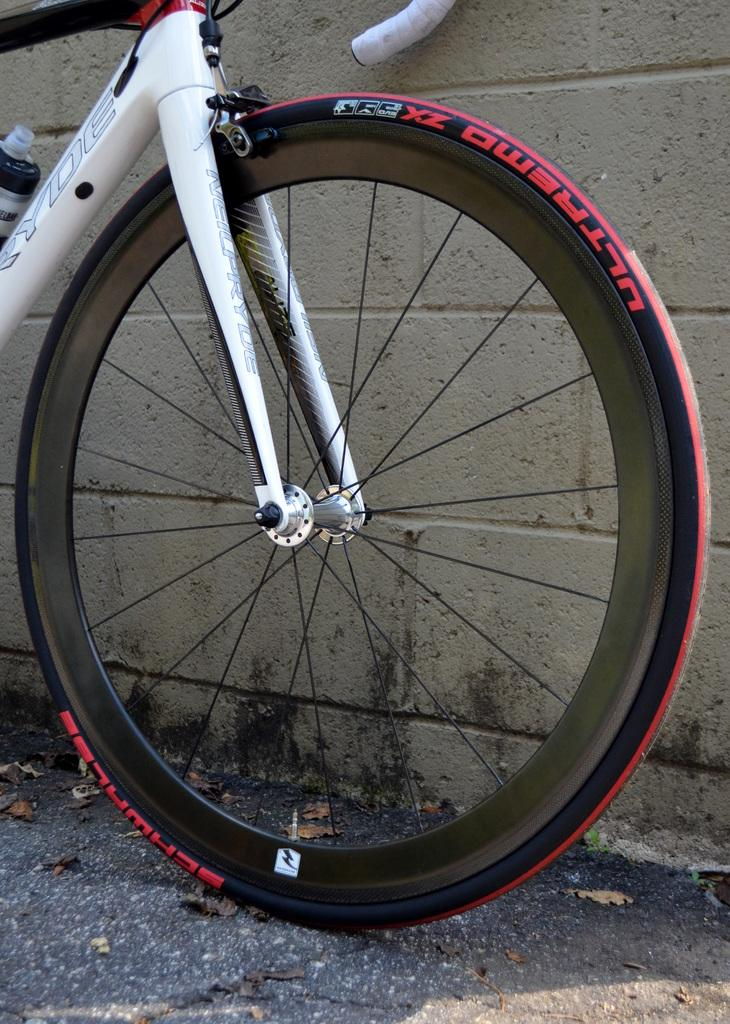What is the main subject of the image? The main subject of the image is a bicycle. Where is the bicycle located? The bicycle is on a road. What can be seen in the background of the image? There is a wall in the background of the image. What type of quince is being crushed by the bicycle in the image? There is no quince present in the image, and the bicycle is not crushing anything. 